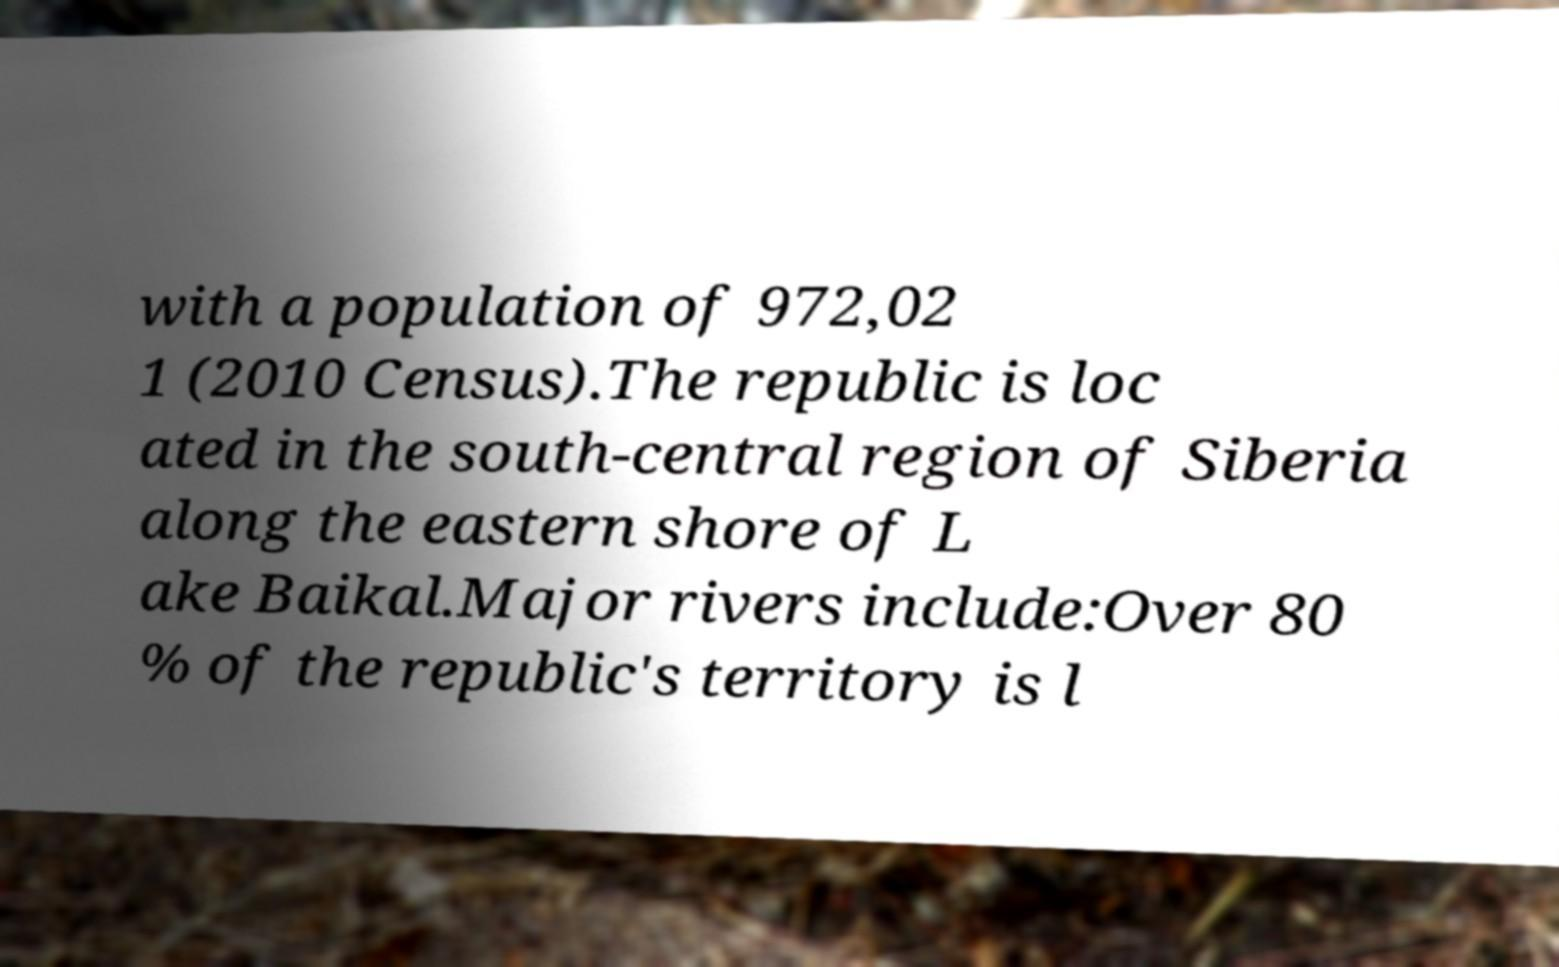Can you accurately transcribe the text from the provided image for me? with a population of 972,02 1 (2010 Census).The republic is loc ated in the south-central region of Siberia along the eastern shore of L ake Baikal.Major rivers include:Over 80 % of the republic's territory is l 